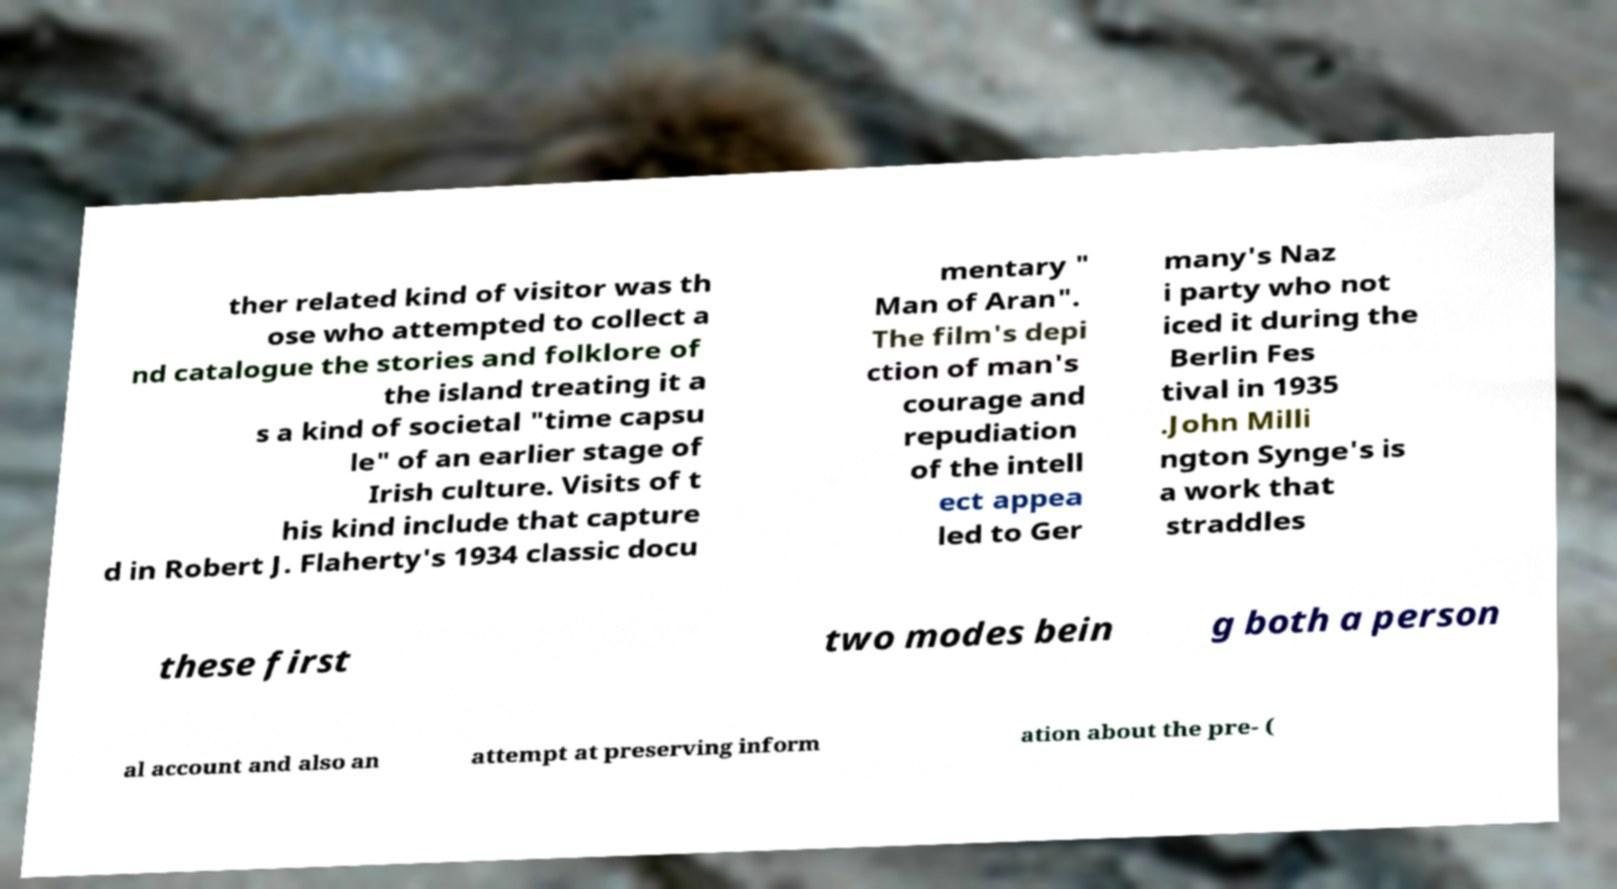What messages or text are displayed in this image? I need them in a readable, typed format. ther related kind of visitor was th ose who attempted to collect a nd catalogue the stories and folklore of the island treating it a s a kind of societal "time capsu le" of an earlier stage of Irish culture. Visits of t his kind include that capture d in Robert J. Flaherty's 1934 classic docu mentary " Man of Aran". The film's depi ction of man's courage and repudiation of the intell ect appea led to Ger many's Naz i party who not iced it during the Berlin Fes tival in 1935 .John Milli ngton Synge's is a work that straddles these first two modes bein g both a person al account and also an attempt at preserving inform ation about the pre- ( 